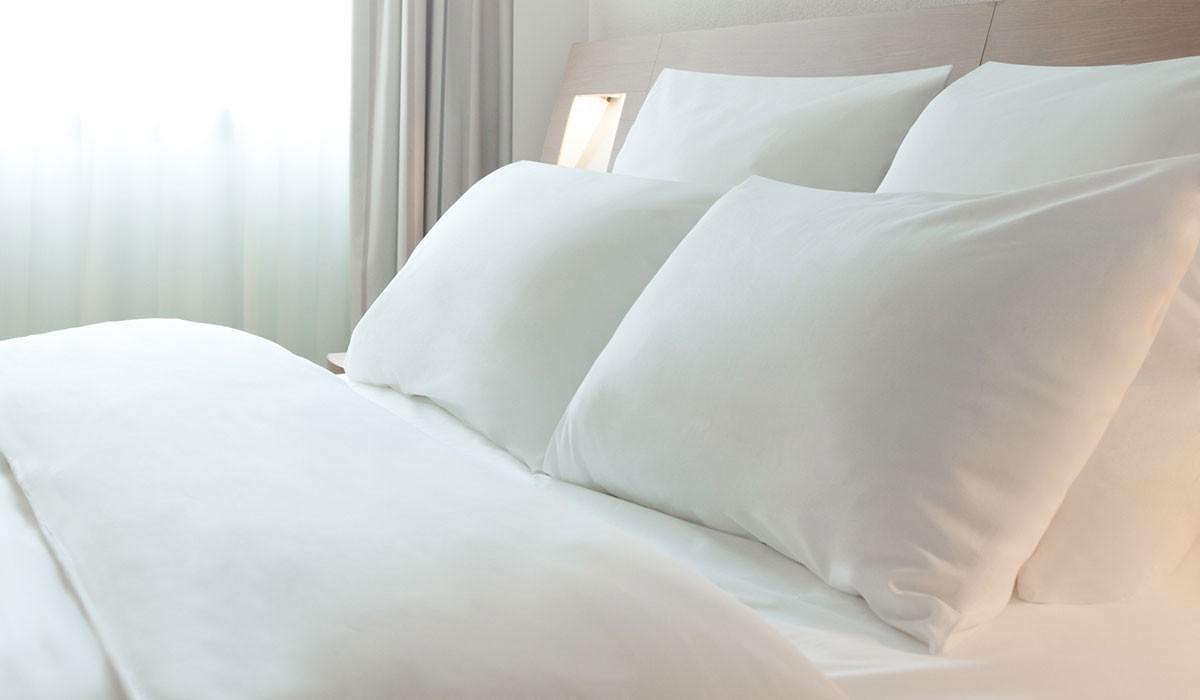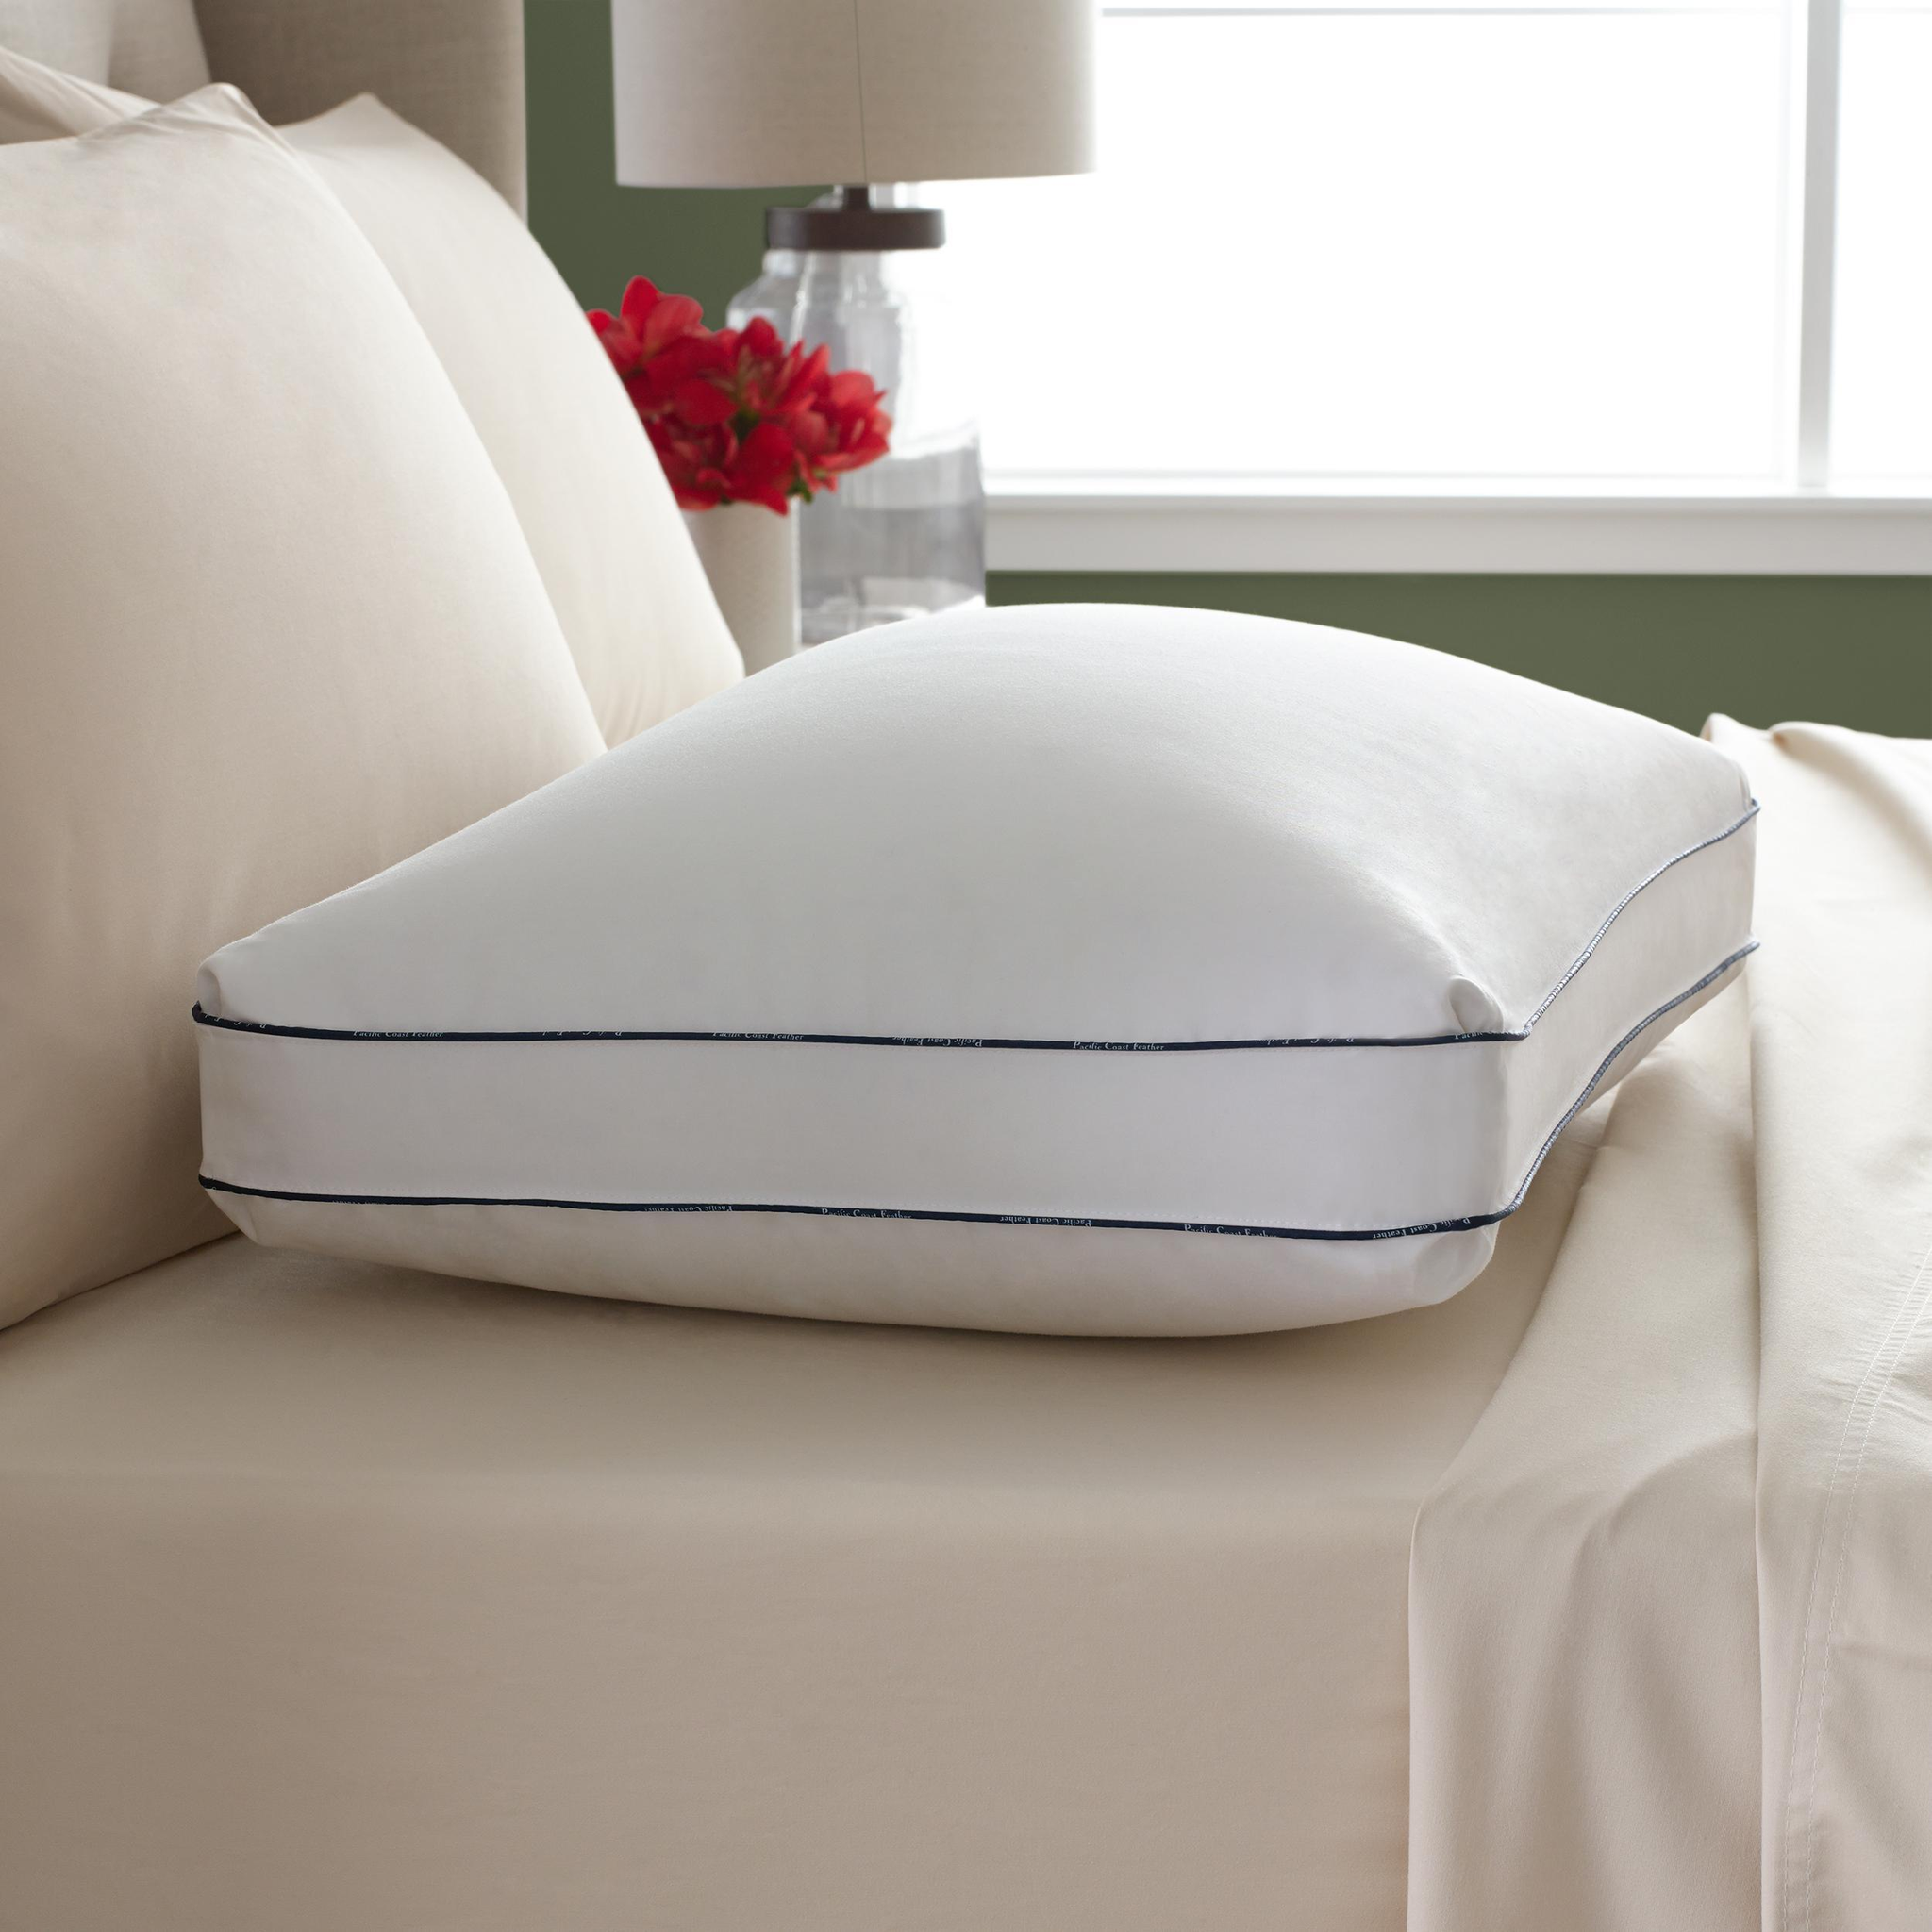The first image is the image on the left, the second image is the image on the right. Assess this claim about the two images: "There is a vase of flowers in the image on the left.". Correct or not? Answer yes or no. No. 